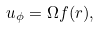<formula> <loc_0><loc_0><loc_500><loc_500>u _ { \phi } = \Omega f ( r ) ,</formula> 